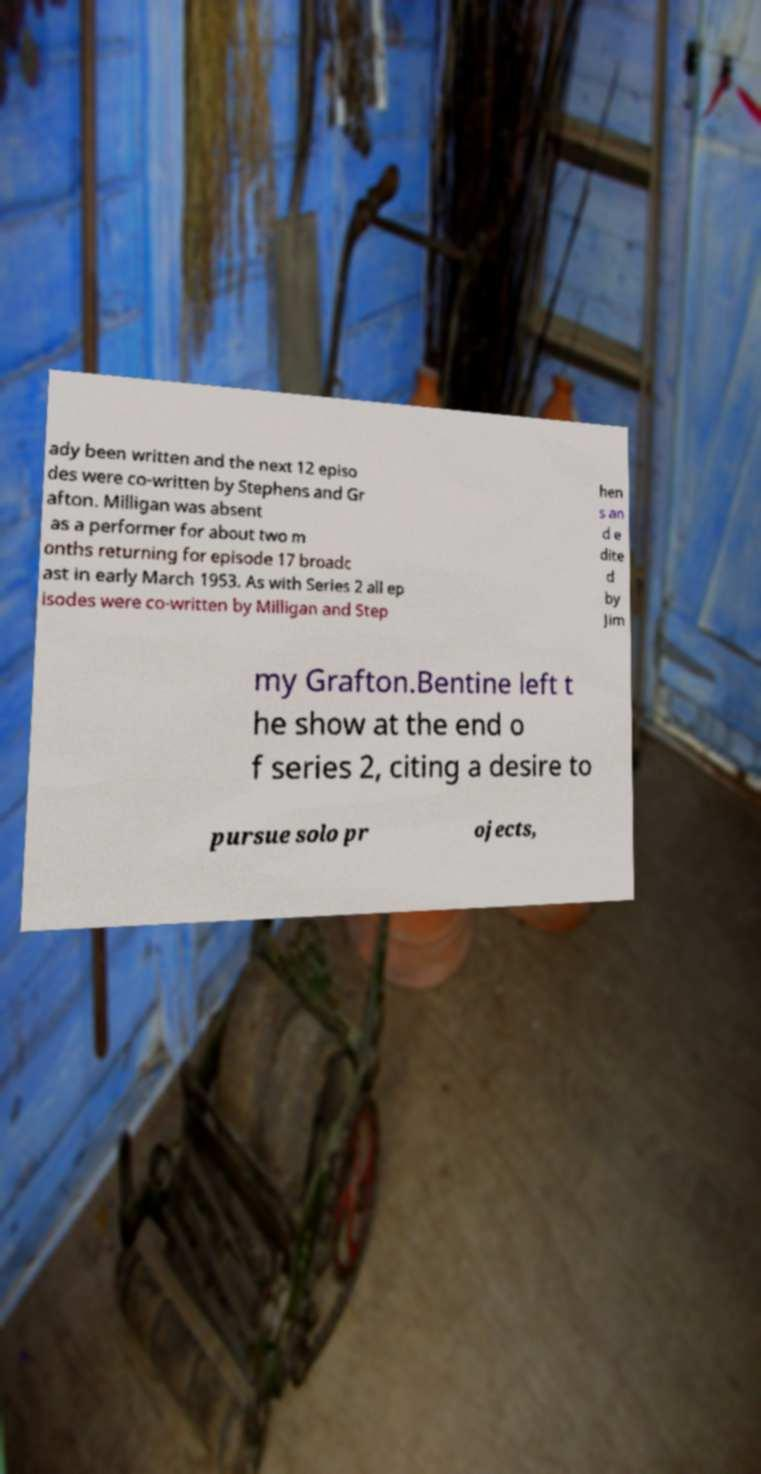Please read and relay the text visible in this image. What does it say? ady been written and the next 12 episo des were co-written by Stephens and Gr afton. Milligan was absent as a performer for about two m onths returning for episode 17 broadc ast in early March 1953. As with Series 2 all ep isodes were co-written by Milligan and Step hen s an d e dite d by Jim my Grafton.Bentine left t he show at the end o f series 2, citing a desire to pursue solo pr ojects, 